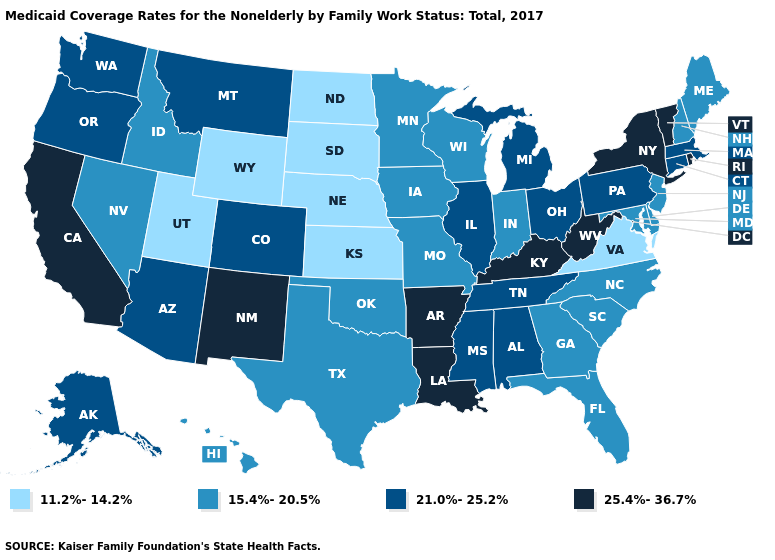What is the highest value in states that border Tennessee?
Write a very short answer. 25.4%-36.7%. Name the states that have a value in the range 15.4%-20.5%?
Be succinct. Delaware, Florida, Georgia, Hawaii, Idaho, Indiana, Iowa, Maine, Maryland, Minnesota, Missouri, Nevada, New Hampshire, New Jersey, North Carolina, Oklahoma, South Carolina, Texas, Wisconsin. What is the highest value in states that border Oregon?
Write a very short answer. 25.4%-36.7%. Name the states that have a value in the range 25.4%-36.7%?
Answer briefly. Arkansas, California, Kentucky, Louisiana, New Mexico, New York, Rhode Island, Vermont, West Virginia. Does Virginia have the lowest value in the USA?
Concise answer only. Yes. What is the value of Hawaii?
Be succinct. 15.4%-20.5%. Does the map have missing data?
Answer briefly. No. Which states have the lowest value in the USA?
Answer briefly. Kansas, Nebraska, North Dakota, South Dakota, Utah, Virginia, Wyoming. Name the states that have a value in the range 21.0%-25.2%?
Write a very short answer. Alabama, Alaska, Arizona, Colorado, Connecticut, Illinois, Massachusetts, Michigan, Mississippi, Montana, Ohio, Oregon, Pennsylvania, Tennessee, Washington. What is the value of Wisconsin?
Give a very brief answer. 15.4%-20.5%. What is the highest value in states that border Nevada?
Keep it brief. 25.4%-36.7%. Which states have the lowest value in the USA?
Short answer required. Kansas, Nebraska, North Dakota, South Dakota, Utah, Virginia, Wyoming. Name the states that have a value in the range 15.4%-20.5%?
Be succinct. Delaware, Florida, Georgia, Hawaii, Idaho, Indiana, Iowa, Maine, Maryland, Minnesota, Missouri, Nevada, New Hampshire, New Jersey, North Carolina, Oklahoma, South Carolina, Texas, Wisconsin. How many symbols are there in the legend?
Write a very short answer. 4. Which states have the lowest value in the West?
Concise answer only. Utah, Wyoming. 